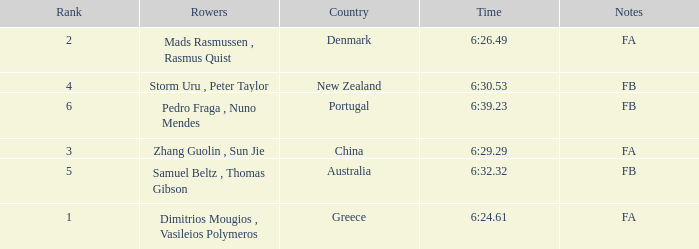What is the names of the rowers that the time was 6:24.61? Dimitrios Mougios , Vasileios Polymeros. 